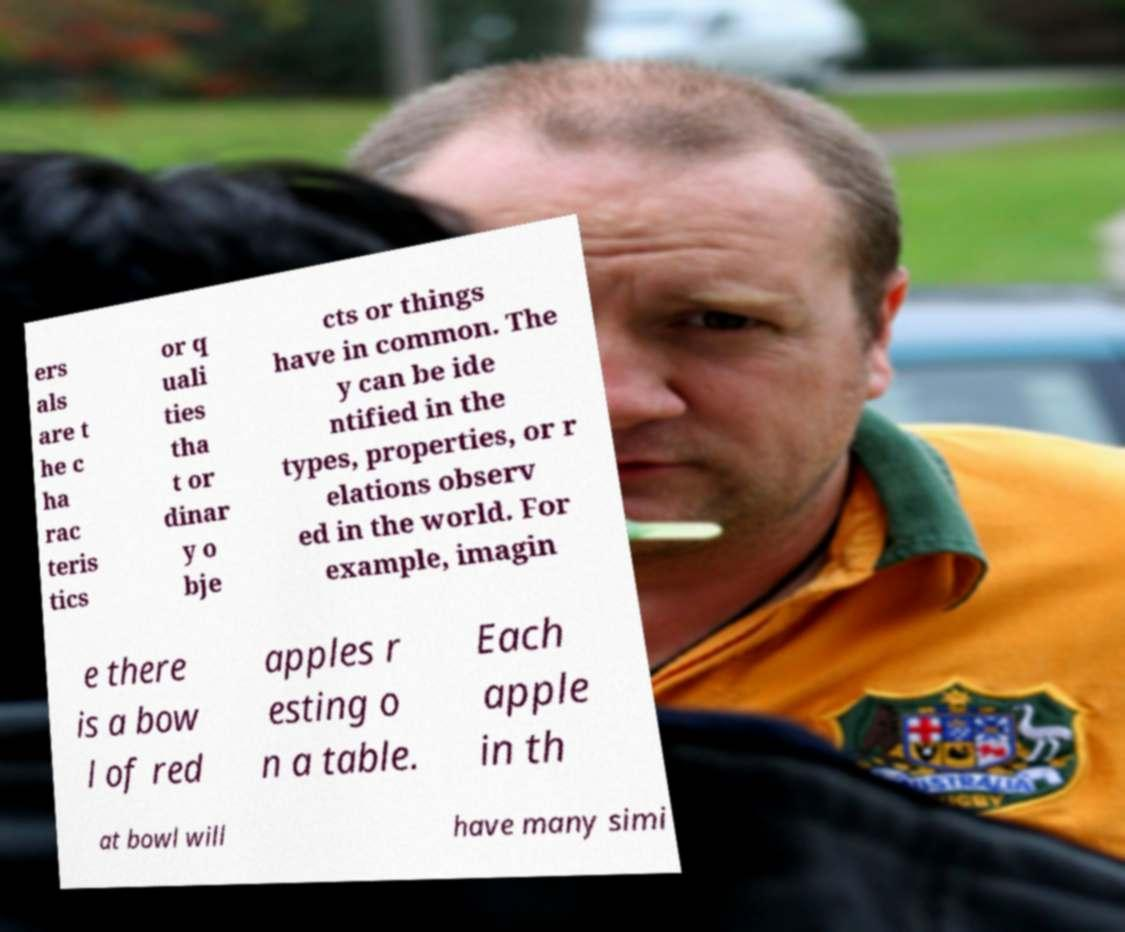Could you assist in decoding the text presented in this image and type it out clearly? ers als are t he c ha rac teris tics or q uali ties tha t or dinar y o bje cts or things have in common. The y can be ide ntified in the types, properties, or r elations observ ed in the world. For example, imagin e there is a bow l of red apples r esting o n a table. Each apple in th at bowl will have many simi 